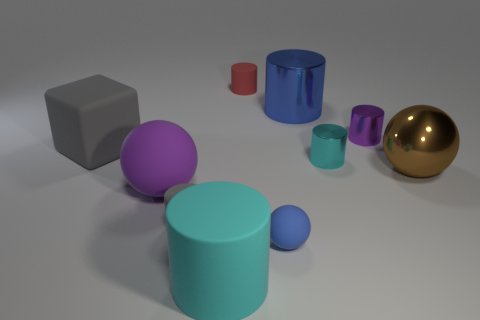There is a shiny thing that is to the left of the tiny purple cylinder and in front of the purple metallic cylinder; what is its color?
Your answer should be very brief. Cyan. Is the number of big red metallic spheres greater than the number of rubber cylinders?
Offer a terse response. No. There is a purple object right of the small gray cylinder; is it the same shape as the purple matte object?
Your answer should be compact. No. How many shiny objects are blue cylinders or small red blocks?
Provide a succinct answer. 1. Are there any cyan objects that have the same material as the big gray cube?
Offer a terse response. Yes. What material is the large cyan cylinder?
Make the answer very short. Rubber. What shape is the small thing on the left side of the big thing that is in front of the blue object that is left of the blue cylinder?
Give a very brief answer. Cylinder. Are there more tiny purple objects on the left side of the blue shiny cylinder than small brown matte cylinders?
Keep it short and to the point. No. There is a tiny purple metal object; is it the same shape as the large rubber object that is in front of the big purple matte ball?
Provide a short and direct response. Yes. There is a small rubber thing that is the same color as the large block; what shape is it?
Offer a very short reply. Cylinder. 